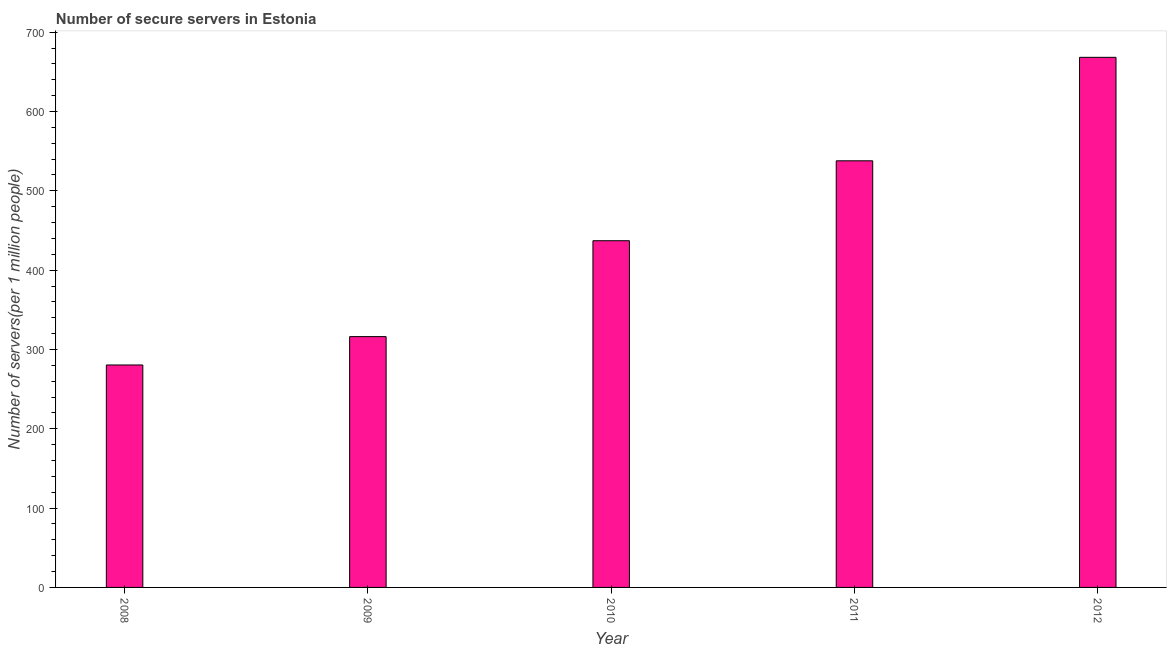Does the graph contain grids?
Offer a very short reply. No. What is the title of the graph?
Provide a succinct answer. Number of secure servers in Estonia. What is the label or title of the Y-axis?
Ensure brevity in your answer.  Number of servers(per 1 million people). What is the number of secure internet servers in 2010?
Offer a very short reply. 437.11. Across all years, what is the maximum number of secure internet servers?
Keep it short and to the point. 668.33. Across all years, what is the minimum number of secure internet servers?
Your answer should be very brief. 280.46. What is the sum of the number of secure internet servers?
Make the answer very short. 2240. What is the difference between the number of secure internet servers in 2009 and 2011?
Keep it short and to the point. -221.66. What is the average number of secure internet servers per year?
Ensure brevity in your answer.  448. What is the median number of secure internet servers?
Your answer should be compact. 437.11. In how many years, is the number of secure internet servers greater than 120 ?
Offer a very short reply. 5. What is the ratio of the number of secure internet servers in 2011 to that in 2012?
Ensure brevity in your answer.  0.81. Is the difference between the number of secure internet servers in 2011 and 2012 greater than the difference between any two years?
Make the answer very short. No. What is the difference between the highest and the second highest number of secure internet servers?
Give a very brief answer. 130.45. Is the sum of the number of secure internet servers in 2011 and 2012 greater than the maximum number of secure internet servers across all years?
Provide a succinct answer. Yes. What is the difference between the highest and the lowest number of secure internet servers?
Offer a very short reply. 387.87. Are all the bars in the graph horizontal?
Provide a short and direct response. No. What is the difference between two consecutive major ticks on the Y-axis?
Ensure brevity in your answer.  100. What is the Number of servers(per 1 million people) in 2008?
Keep it short and to the point. 280.46. What is the Number of servers(per 1 million people) in 2009?
Offer a very short reply. 316.22. What is the Number of servers(per 1 million people) of 2010?
Give a very brief answer. 437.11. What is the Number of servers(per 1 million people) in 2011?
Your answer should be very brief. 537.88. What is the Number of servers(per 1 million people) of 2012?
Your answer should be very brief. 668.33. What is the difference between the Number of servers(per 1 million people) in 2008 and 2009?
Provide a succinct answer. -35.76. What is the difference between the Number of servers(per 1 million people) in 2008 and 2010?
Keep it short and to the point. -156.65. What is the difference between the Number of servers(per 1 million people) in 2008 and 2011?
Make the answer very short. -257.42. What is the difference between the Number of servers(per 1 million people) in 2008 and 2012?
Give a very brief answer. -387.87. What is the difference between the Number of servers(per 1 million people) in 2009 and 2010?
Ensure brevity in your answer.  -120.89. What is the difference between the Number of servers(per 1 million people) in 2009 and 2011?
Ensure brevity in your answer.  -221.66. What is the difference between the Number of servers(per 1 million people) in 2009 and 2012?
Keep it short and to the point. -352.11. What is the difference between the Number of servers(per 1 million people) in 2010 and 2011?
Your response must be concise. -100.77. What is the difference between the Number of servers(per 1 million people) in 2010 and 2012?
Your answer should be compact. -231.22. What is the difference between the Number of servers(per 1 million people) in 2011 and 2012?
Keep it short and to the point. -130.45. What is the ratio of the Number of servers(per 1 million people) in 2008 to that in 2009?
Ensure brevity in your answer.  0.89. What is the ratio of the Number of servers(per 1 million people) in 2008 to that in 2010?
Provide a succinct answer. 0.64. What is the ratio of the Number of servers(per 1 million people) in 2008 to that in 2011?
Your answer should be compact. 0.52. What is the ratio of the Number of servers(per 1 million people) in 2008 to that in 2012?
Give a very brief answer. 0.42. What is the ratio of the Number of servers(per 1 million people) in 2009 to that in 2010?
Provide a short and direct response. 0.72. What is the ratio of the Number of servers(per 1 million people) in 2009 to that in 2011?
Your answer should be compact. 0.59. What is the ratio of the Number of servers(per 1 million people) in 2009 to that in 2012?
Keep it short and to the point. 0.47. What is the ratio of the Number of servers(per 1 million people) in 2010 to that in 2011?
Make the answer very short. 0.81. What is the ratio of the Number of servers(per 1 million people) in 2010 to that in 2012?
Offer a very short reply. 0.65. What is the ratio of the Number of servers(per 1 million people) in 2011 to that in 2012?
Offer a very short reply. 0.81. 